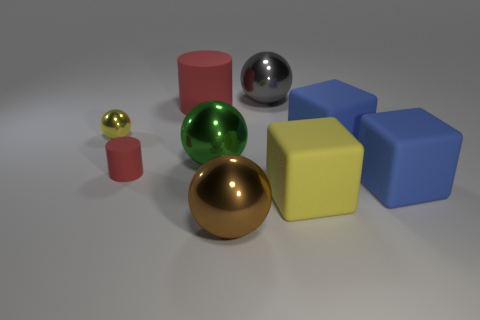Which objects in the image are reflective? The objects that exhibit reflectivity are the silver sphere and the gold sphere. Their surfaces are polished and shiny, which is why they reflect the environment and light around them. 